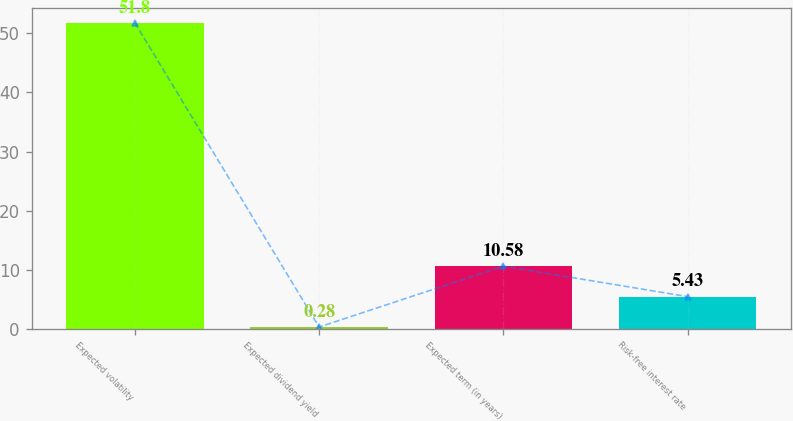<chart> <loc_0><loc_0><loc_500><loc_500><bar_chart><fcel>Expected volatility<fcel>Expected dividend yield<fcel>Expected term (in years)<fcel>Risk-free interest rate<nl><fcel>51.8<fcel>0.28<fcel>10.58<fcel>5.43<nl></chart> 